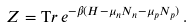Convert formula to latex. <formula><loc_0><loc_0><loc_500><loc_500>Z = { \mathrm T r } \, e ^ { - \beta ( H - \mu _ { n } N _ { n } - \mu _ { p } N _ { p } ) } \, .</formula> 